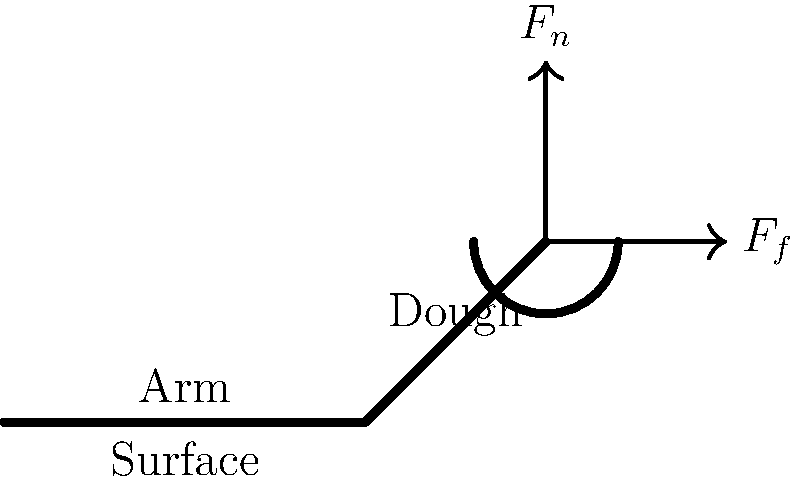When kneading dough for traditional Iranian bread, such as sangak or barbari, the baker applies a downward force on the dough. If the coefficient of friction between the dough and the surface is 0.4, and the normal force ($F_n$) applied by the baker is 50 N, what is the maximum friction force ($F_f$) that can be generated between the dough and the surface? To solve this problem, we'll follow these steps:

1. Identify the given information:
   - Coefficient of friction (μ) = 0.4
   - Normal force ($F_n$) = 50 N

2. Recall the formula for maximum static friction force:
   $F_f = μ \cdot F_n$

3. Substitute the known values into the formula:
   $F_f = 0.4 \cdot 50 \text{ N}$

4. Calculate the result:
   $F_f = 20 \text{ N}$

The maximum friction force that can be generated between the dough and the surface is 20 N. This force allows the dough to resist sliding on the surface while being kneaded, which is crucial for properly working the gluten in traditional Iranian bread making.
Answer: 20 N 